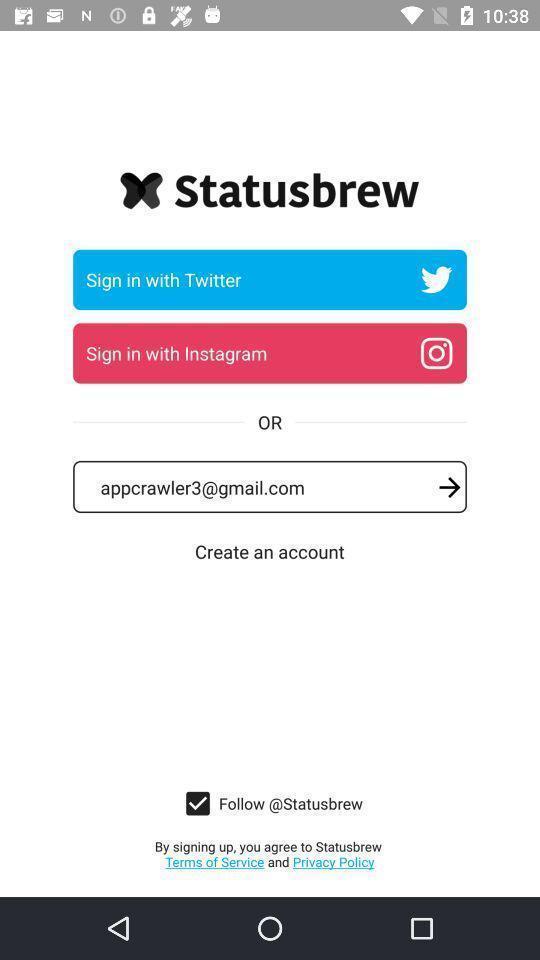Provide a description of this screenshot. Sign in page for the social media app. 